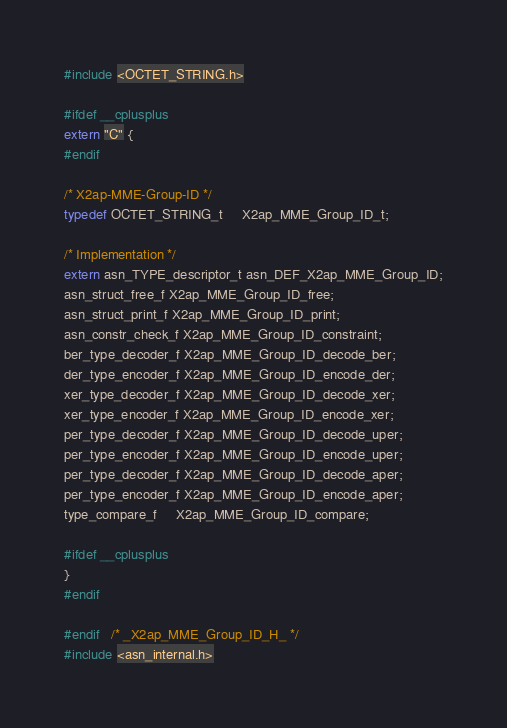<code> <loc_0><loc_0><loc_500><loc_500><_C_>#include <OCTET_STRING.h>

#ifdef __cplusplus
extern "C" {
#endif

/* X2ap-MME-Group-ID */
typedef OCTET_STRING_t	 X2ap_MME_Group_ID_t;

/* Implementation */
extern asn_TYPE_descriptor_t asn_DEF_X2ap_MME_Group_ID;
asn_struct_free_f X2ap_MME_Group_ID_free;
asn_struct_print_f X2ap_MME_Group_ID_print;
asn_constr_check_f X2ap_MME_Group_ID_constraint;
ber_type_decoder_f X2ap_MME_Group_ID_decode_ber;
der_type_encoder_f X2ap_MME_Group_ID_encode_der;
xer_type_decoder_f X2ap_MME_Group_ID_decode_xer;
xer_type_encoder_f X2ap_MME_Group_ID_encode_xer;
per_type_decoder_f X2ap_MME_Group_ID_decode_uper;
per_type_encoder_f X2ap_MME_Group_ID_encode_uper;
per_type_decoder_f X2ap_MME_Group_ID_decode_aper;
per_type_encoder_f X2ap_MME_Group_ID_encode_aper;
type_compare_f     X2ap_MME_Group_ID_compare;

#ifdef __cplusplus
}
#endif

#endif	/* _X2ap_MME_Group_ID_H_ */
#include <asn_internal.h>
</code> 